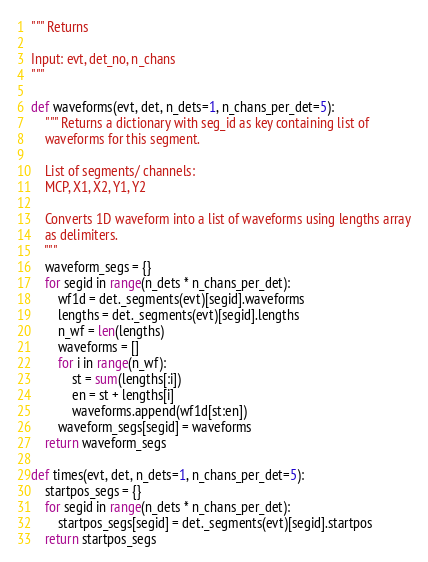Convert code to text. <code><loc_0><loc_0><loc_500><loc_500><_Cython_>""" Returns 

Input: evt, det_no, n_chans
"""

def waveforms(evt, det, n_dets=1, n_chans_per_det=5): 
    """ Returns a dictionary with seg_id as key containing list of 
    waveforms for this segment.
    
    List of segments/ channels:
    MCP, X1, X2, Y1, Y2

    Converts 1D waveform into a list of waveforms using lengths array
    as delimiters.
    """
    waveform_segs = {}
    for segid in range(n_dets * n_chans_per_det):
        wf1d = det._segments(evt)[segid].waveforms
        lengths = det._segments(evt)[segid].lengths
        n_wf = len(lengths)
        waveforms = []
        for i in range(n_wf):
            st = sum(lengths[:i])
            en = st + lengths[i]
            waveforms.append(wf1d[st:en])
        waveform_segs[segid] = waveforms
    return waveform_segs

def times(evt, det, n_dets=1, n_chans_per_det=5):
    startpos_segs = {}
    for segid in range(n_dets * n_chans_per_det):
        startpos_segs[segid] = det._segments(evt)[segid].startpos
    return startpos_segs
</code> 